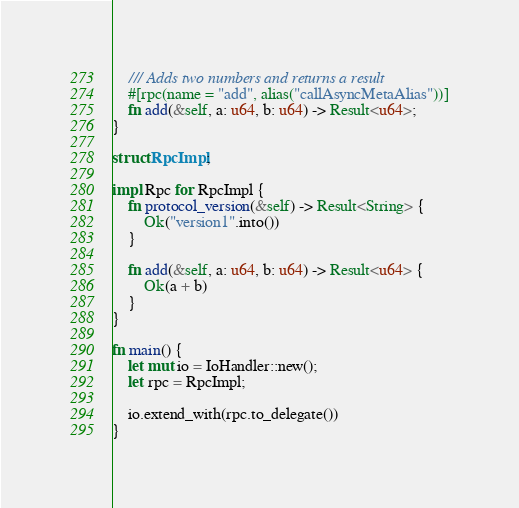<code> <loc_0><loc_0><loc_500><loc_500><_Rust_>	/// Adds two numbers and returns a result
	#[rpc(name = "add", alias("callAsyncMetaAlias"))]
	fn add(&self, a: u64, b: u64) -> Result<u64>;
}

struct RpcImpl;

impl Rpc for RpcImpl {
	fn protocol_version(&self) -> Result<String> {
		Ok("version1".into())
	}

	fn add(&self, a: u64, b: u64) -> Result<u64> {
		Ok(a + b)
	}
}

fn main() {
	let mut io = IoHandler::new();
	let rpc = RpcImpl;

	io.extend_with(rpc.to_delegate())
}
</code> 